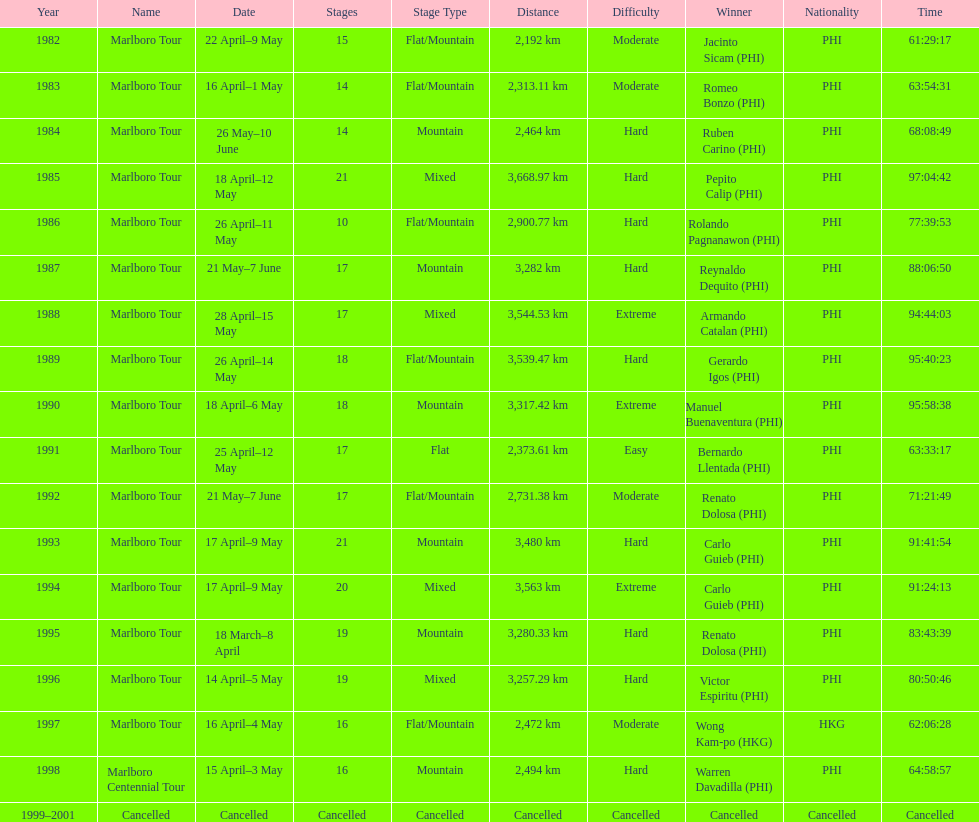What was the total number of winners before the tour was canceled? 17. 